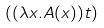Convert formula to latex. <formula><loc_0><loc_0><loc_500><loc_500>( ( \lambda x . A ( x ) ) t )</formula> 